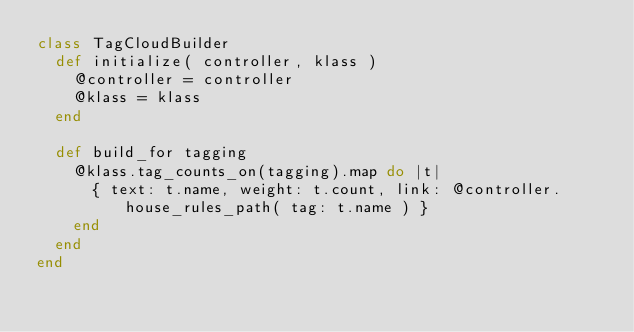<code> <loc_0><loc_0><loc_500><loc_500><_Ruby_>class TagCloudBuilder
  def initialize( controller, klass )
    @controller = controller
    @klass = klass
  end

  def build_for tagging
    @klass.tag_counts_on(tagging).map do |t|
      { text: t.name, weight: t.count, link: @controller.house_rules_path( tag: t.name ) }
    end
  end
end
</code> 